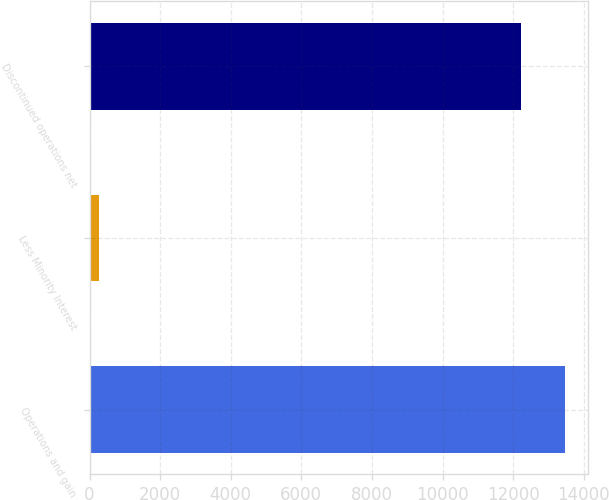<chart> <loc_0><loc_0><loc_500><loc_500><bar_chart><fcel>Operations and gain<fcel>Less Minority Interest<fcel>Discontinued operations net<nl><fcel>13460.3<fcel>281<fcel>12220<nl></chart> 